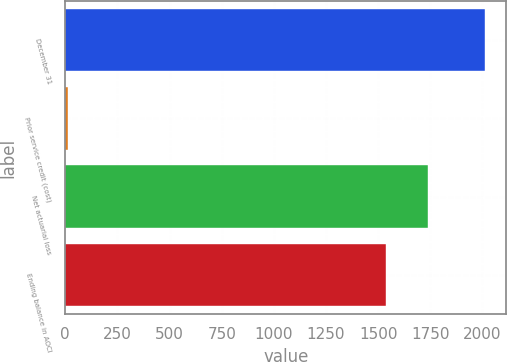<chart> <loc_0><loc_0><loc_500><loc_500><bar_chart><fcel>December 31<fcel>Prior service credit (cost)<fcel>Net actuarial loss<fcel>Ending balance in AOCI<nl><fcel>2013<fcel>12<fcel>1737.1<fcel>1537<nl></chart> 